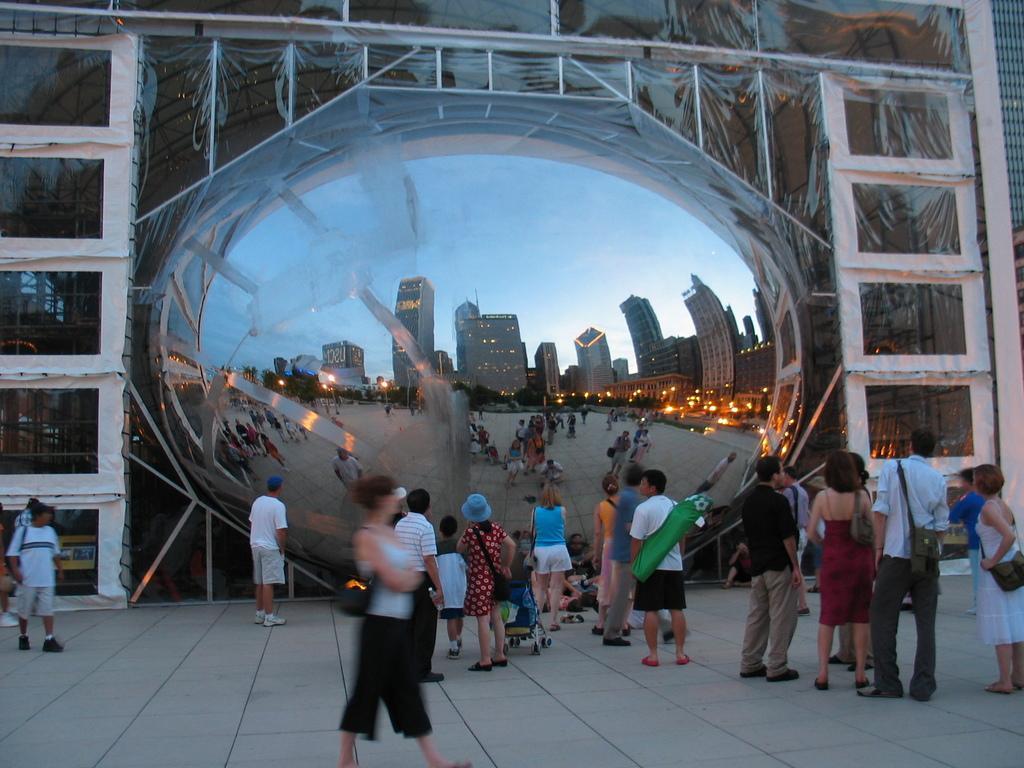Describe this image in one or two sentences. This picture describes about group of people, few are standing and few are walking, and we can see few people wore bags, in the background we can find few buildings and lights. 